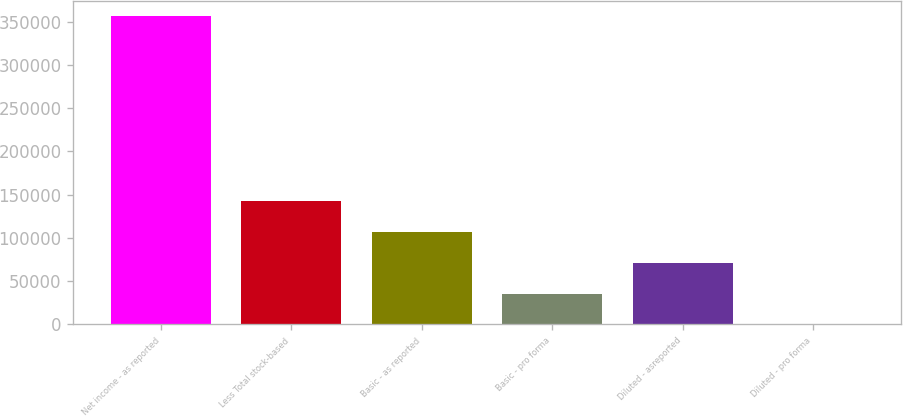Convert chart to OTSL. <chart><loc_0><loc_0><loc_500><loc_500><bar_chart><fcel>Net income - as reported<fcel>Less Total stock-based<fcel>Basic - as reported<fcel>Basic - pro forma<fcel>Diluted - asreported<fcel>Diluted - pro forma<nl><fcel>355961<fcel>142385<fcel>106789<fcel>35596.9<fcel>71192.9<fcel>0.86<nl></chart> 